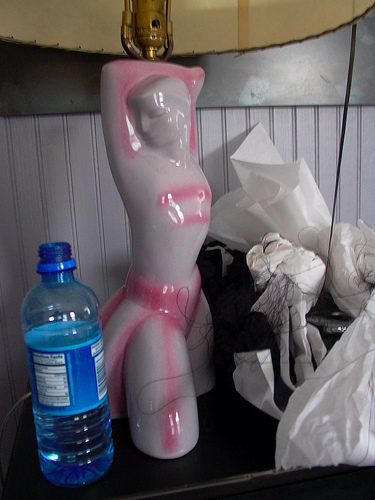<image>
Is the mannequin to the right of the water bottle? Yes. From this viewpoint, the mannequin is positioned to the right side relative to the water bottle. 